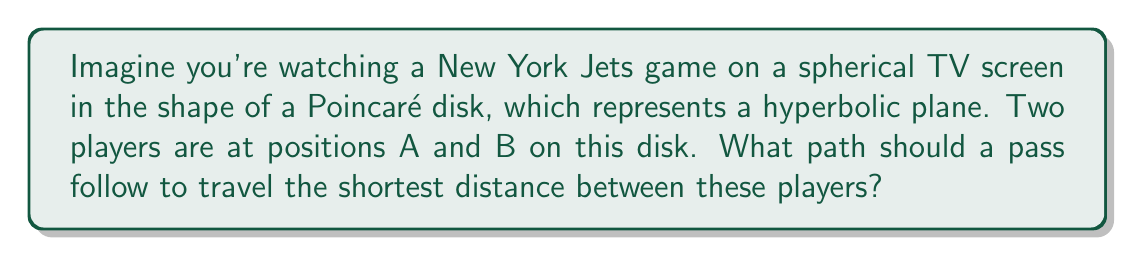Can you solve this math problem? To solve this problem, we need to understand the geometry of the Poincaré disk model of hyperbolic geometry:

1. In the Poincaré disk model, straight lines in hyperbolic geometry are represented by either:
   a) Diameters of the disk
   b) Circular arcs that intersect the boundary of the disk at right angles

2. The shortest path between two points (geodesic) in this model is represented by one of these "straight lines."

3. To find the shortest path between points A and B, we need to construct the unique circular arc that:
   a) Passes through points A and B
   b) Intersects the boundary of the disk at right angles

4. This can be done by following these steps:
   a) Find the center of the circle that contains this arc:
      - It lies on the perpendicular bisector of line segment AB
      - Its distance from the center of the Poincaré disk is greater than the disk's radius
   b) Draw the circular arc from A to B

5. This circular arc represents the geodesic, or shortest path, between A and B in the hyperbolic plane.

[asy]
import geometry;

unitcircle();
pair A = (0.3, 0.4);
pair B = (-0.5, -0.2);
dot("A", A, NE);
dot("B", B, SW);

pair M = (A + B) / 2;
pair perp = rotate(90) * (B - A);
pair C = extension(A, B, M, M + perp);

draw(arc(C, A, B), blue+1);
</asy]

In the context of the football game, this means the optimal path for the pass is not a straight line as we typically see in Euclidean geometry, but rather a curved path following this circular arc.
Answer: A circular arc intersecting the disk's boundary at right angles. 